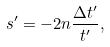<formula> <loc_0><loc_0><loc_500><loc_500>s ^ { \prime } = - 2 n \frac { \Delta t ^ { \prime } } { t ^ { \prime } } ,</formula> 